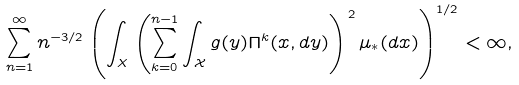<formula> <loc_0><loc_0><loc_500><loc_500>\sum _ { n = 1 } ^ { \infty } n ^ { - 3 / 2 } \left ( \int _ { X } \left ( \sum _ { k = 0 } ^ { n - 1 } \int _ { \mathcal { X } } g ( y ) \Pi ^ { k } ( x , d y ) \right ) ^ { 2 } \mu _ { * } ( d x ) \right ) ^ { 1 / 2 } < \infty ,</formula> 